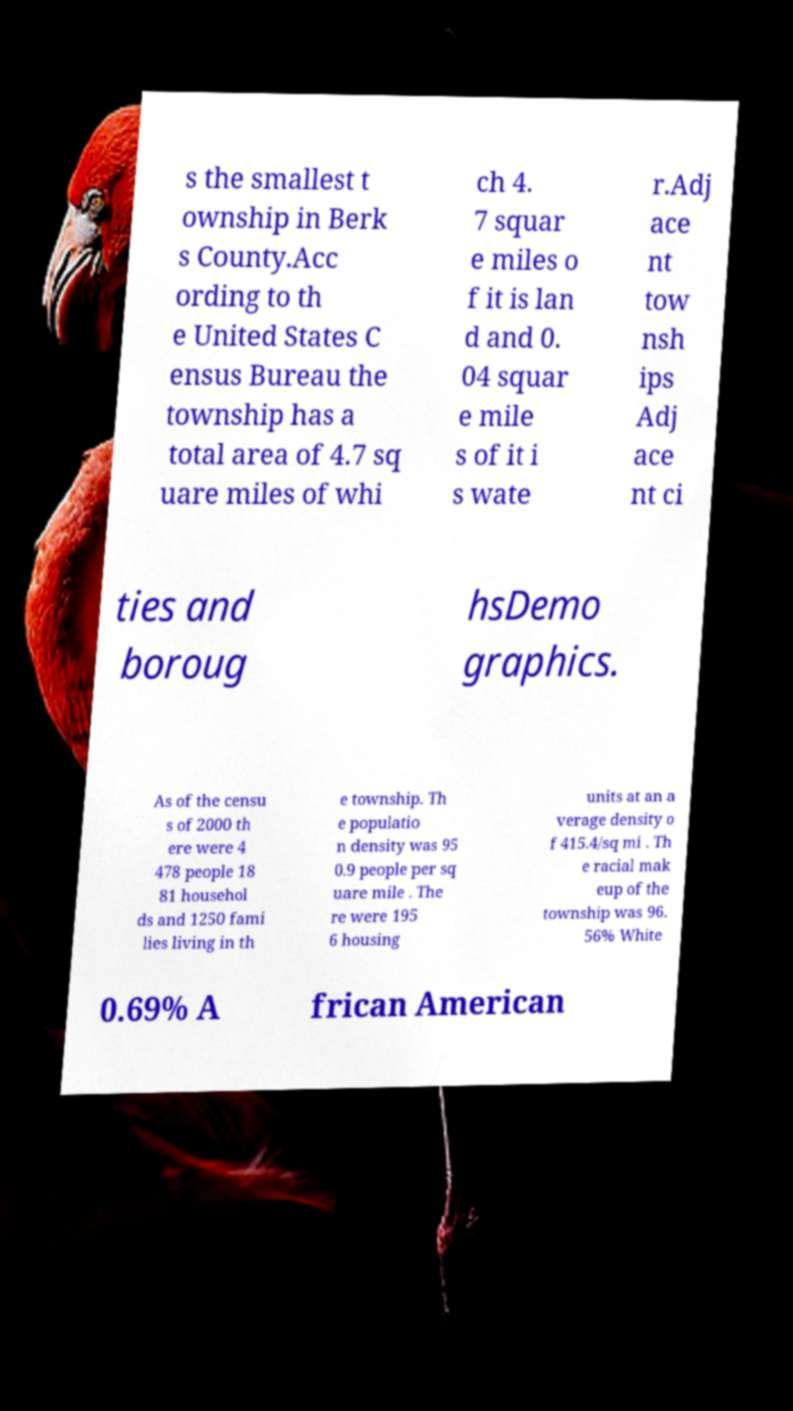Please read and relay the text visible in this image. What does it say? s the smallest t ownship in Berk s County.Acc ording to th e United States C ensus Bureau the township has a total area of 4.7 sq uare miles of whi ch 4. 7 squar e miles o f it is lan d and 0. 04 squar e mile s of it i s wate r.Adj ace nt tow nsh ips Adj ace nt ci ties and boroug hsDemo graphics. As of the censu s of 2000 th ere were 4 478 people 18 81 househol ds and 1250 fami lies living in th e township. Th e populatio n density was 95 0.9 people per sq uare mile . The re were 195 6 housing units at an a verage density o f 415.4/sq mi . Th e racial mak eup of the township was 96. 56% White 0.69% A frican American 